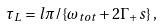Convert formula to latex. <formula><loc_0><loc_0><loc_500><loc_500>\tau _ { L } = l \pi / \{ \omega _ { t o t } + 2 \Gamma _ { + } s \} \, ,</formula> 